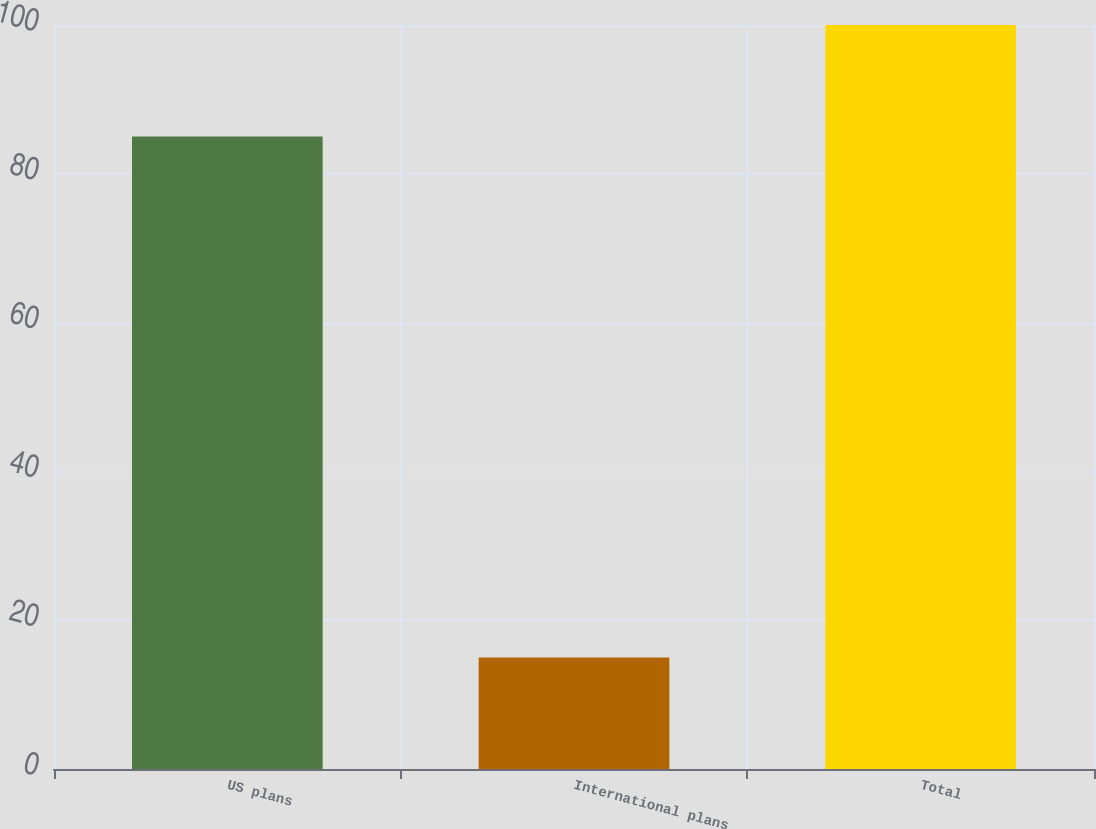Convert chart. <chart><loc_0><loc_0><loc_500><loc_500><bar_chart><fcel>US plans<fcel>International plans<fcel>Total<nl><fcel>85<fcel>15<fcel>100<nl></chart> 